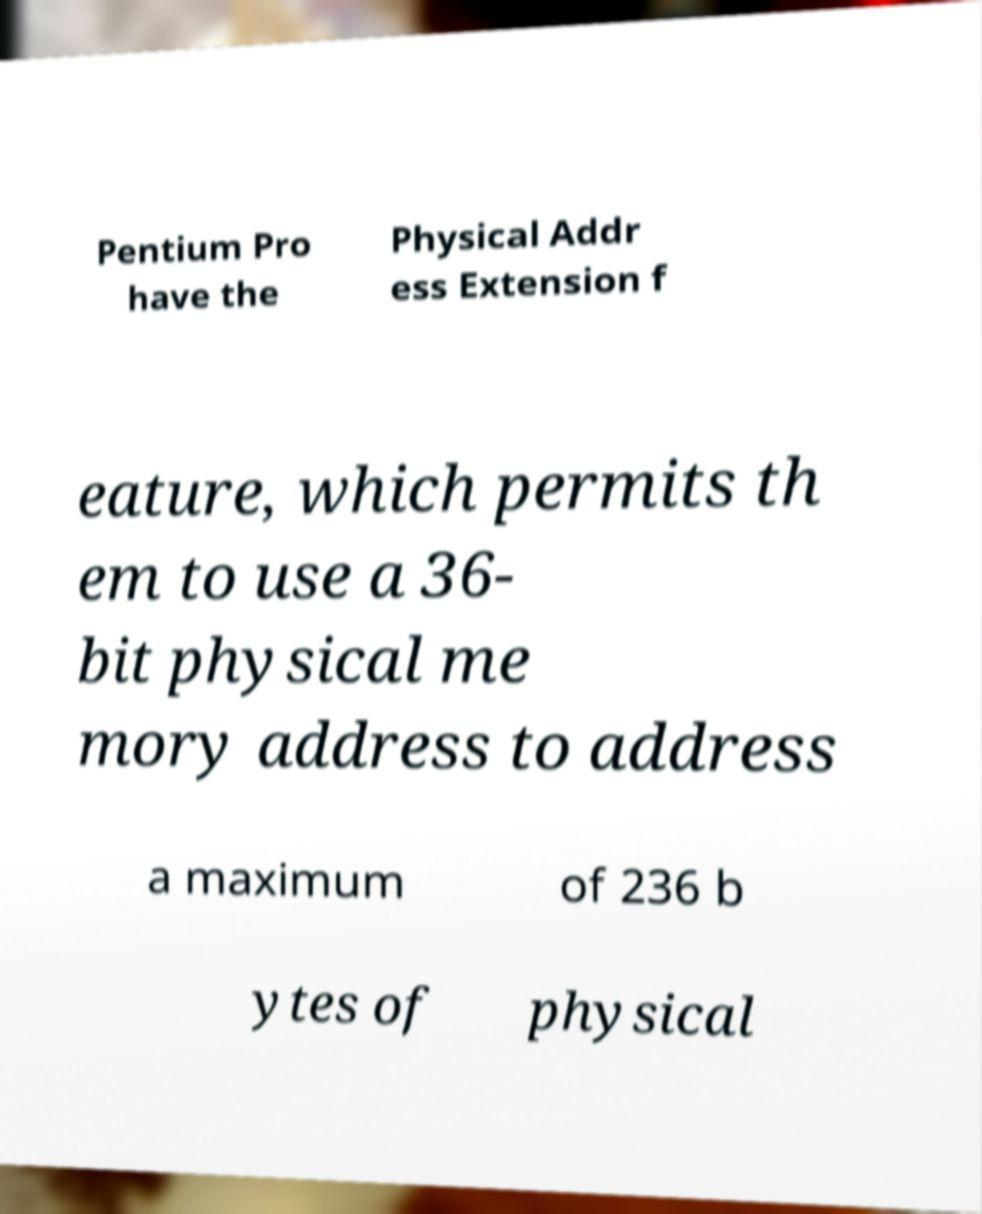Can you read and provide the text displayed in the image?This photo seems to have some interesting text. Can you extract and type it out for me? Pentium Pro have the Physical Addr ess Extension f eature, which permits th em to use a 36- bit physical me mory address to address a maximum of 236 b ytes of physical 